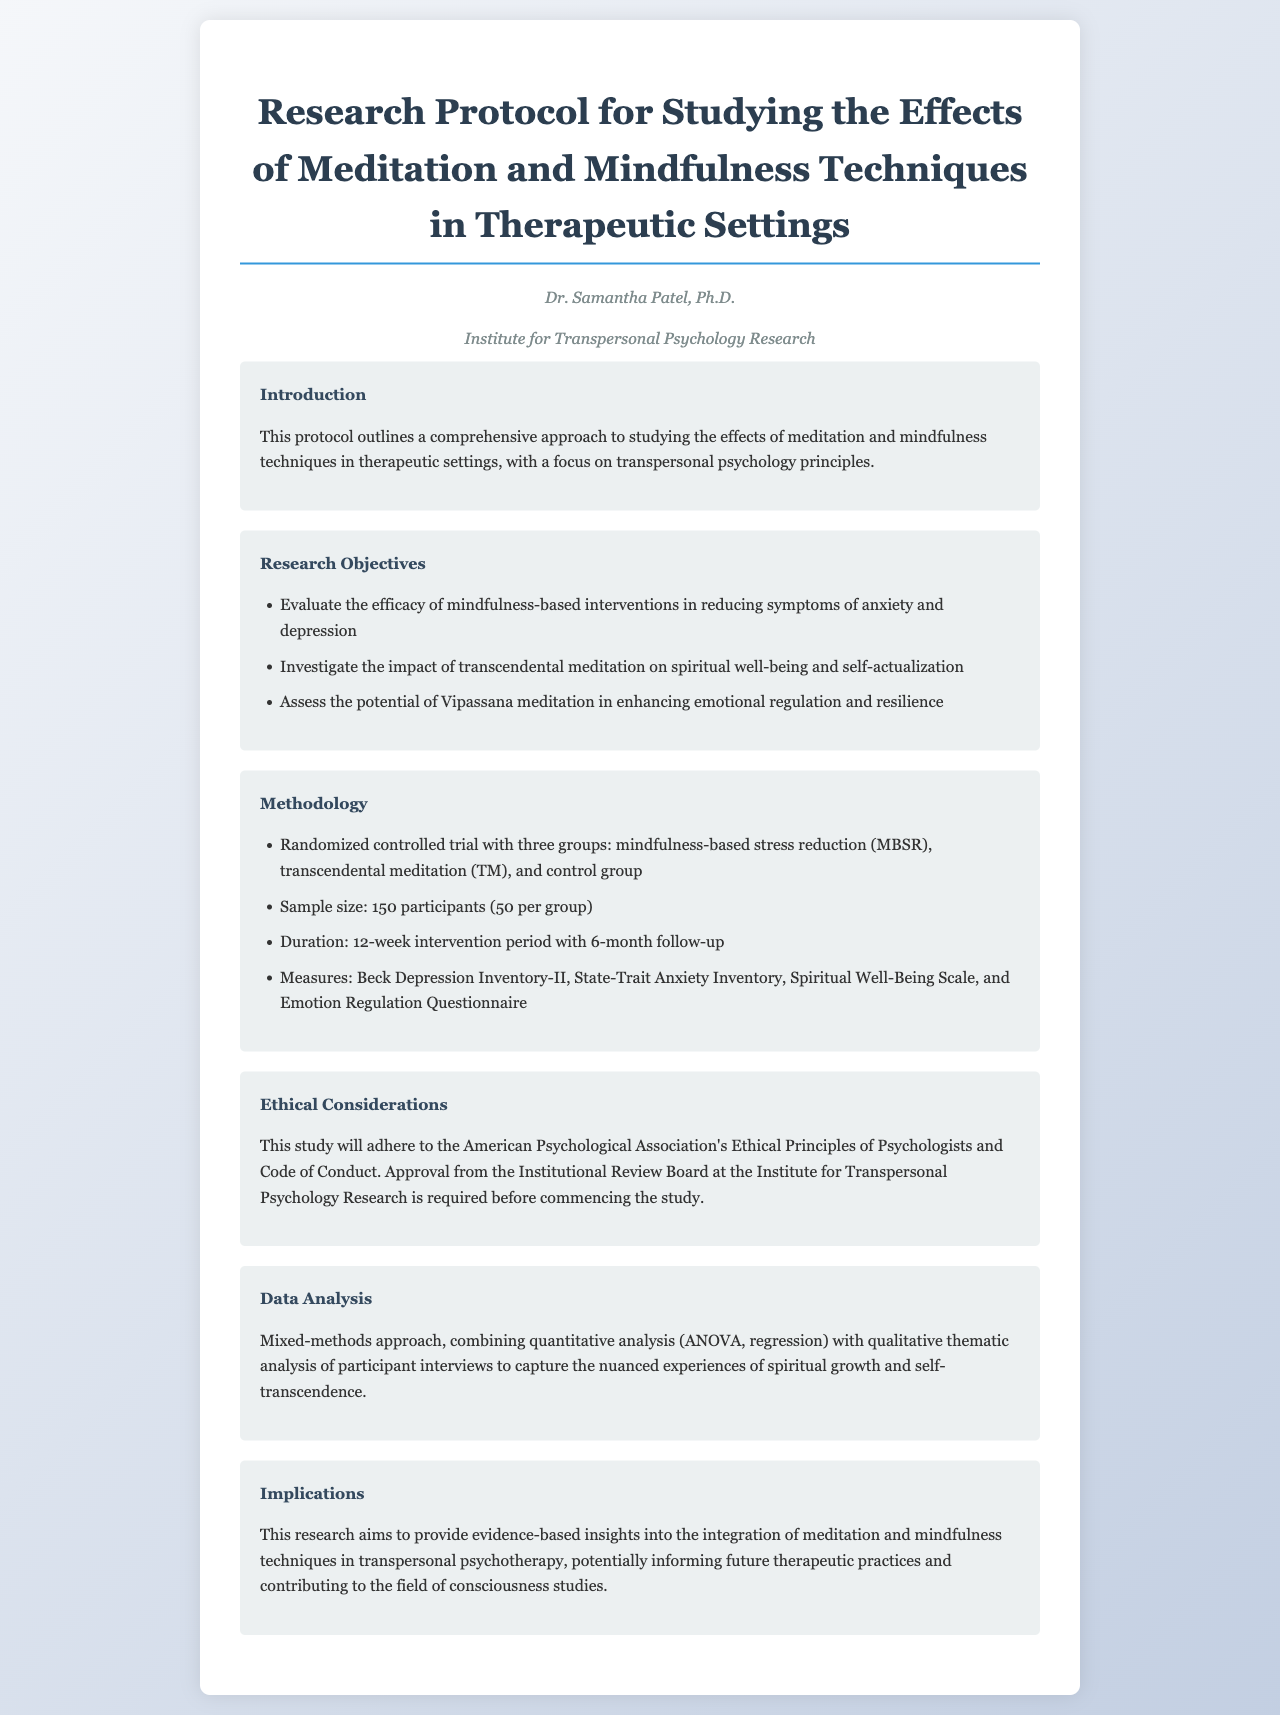what is the title of the document? The title is stated clearly at the beginning of the document as part of the header section.
Answer: Research Protocol for Studying the Effects of Meditation and Mindfulness Techniques in Therapeutic Settings who is the author of the document? The author's name is mentioned in the author section of the document.
Answer: Dr. Samantha Patel, Ph.D how many participants are included in the study? The number of participants is specified in the methodology section under sample size.
Answer: 150 participants what duration is specified for the intervention period? The duration is indicated in the methodology section as part of the study design.
Answer: 12-week intervention period which ethical framework does the study adhere to? The ethical framework is mentioned in the ethical considerations section of the document.
Answer: American Psychological Association's Ethical Principles of Psychologists and Code of Conduct what type of analysis will be used in the study? The type of analysis is detailed in the data analysis section, describing the approach taken.
Answer: Mixed-methods approach what is one of the research objectives listed? The research objective can be found in the research objectives section listing specific goals.
Answer: Evaluate the efficacy of mindfulness-based interventions in reducing symptoms of anxiety and depression how many groups are involved in the randomized controlled trial? The number of groups is detailed in the methodology section regarding the study design.
Answer: Three groups 